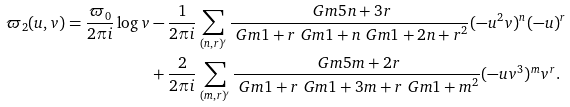Convert formula to latex. <formula><loc_0><loc_0><loc_500><loc_500>\varpi _ { 2 } ( u , v ) = \frac { \varpi _ { 0 } } { 2 \pi i } \log v & - \frac { 1 } { 2 \pi i } \sum _ { ( n , r ) ^ { \prime } } \frac { \ G m { 5 n + 3 r } } { \ G m { 1 + r } \ G m { 1 + n } \ G m { 1 + 2 n + r } ^ { 2 } } ( - u ^ { 2 } v ) ^ { n } ( - u ) ^ { r } \\ & + \frac { 2 } { 2 \pi i } \sum _ { ( m , r ) ^ { \prime } } \frac { \ G m { 5 m + 2 r } } { \ G m { 1 + r } \ G m { 1 + 3 m + r } \ G m { 1 + m } ^ { 2 } } ( - u v ^ { 3 } ) ^ { m } v ^ { r } .</formula> 